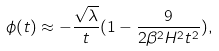Convert formula to latex. <formula><loc_0><loc_0><loc_500><loc_500>\phi ( t ) \approx - \frac { \sqrt { \lambda } } { t } ( 1 - \frac { 9 } { 2 \beta ^ { 2 } H ^ { 2 } t ^ { 2 } } ) ,</formula> 